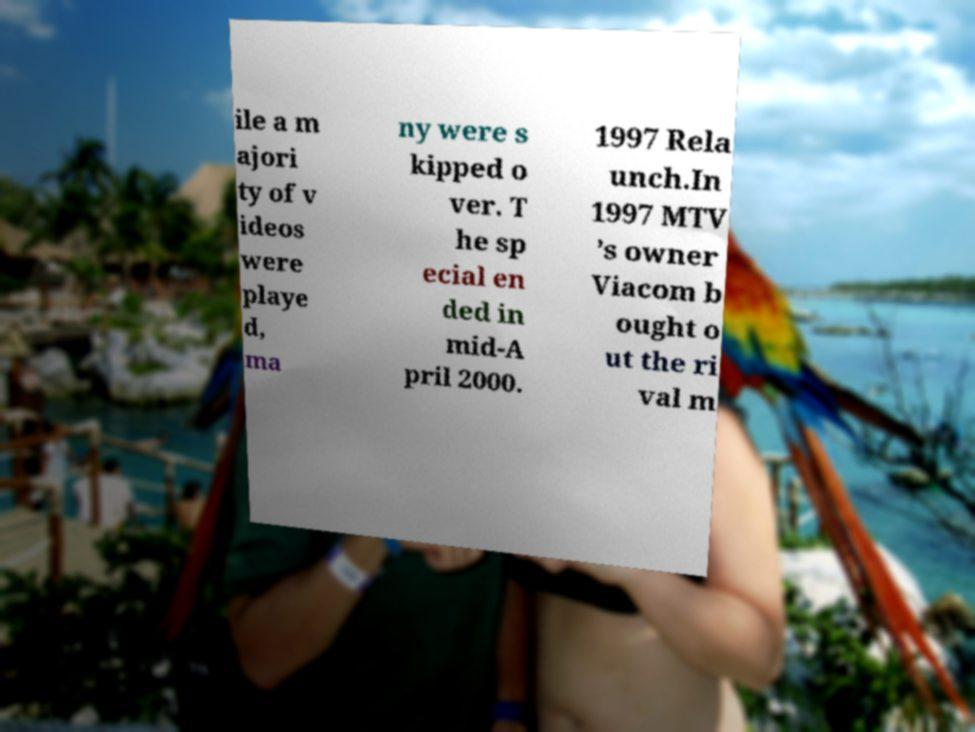There's text embedded in this image that I need extracted. Can you transcribe it verbatim? ile a m ajori ty of v ideos were playe d, ma ny were s kipped o ver. T he sp ecial en ded in mid-A pril 2000. 1997 Rela unch.In 1997 MTV ’s owner Viacom b ought o ut the ri val m 